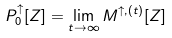Convert formula to latex. <formula><loc_0><loc_0><loc_500><loc_500>P ^ { \uparrow } _ { 0 } [ Z ] = \lim _ { t \to \infty } M ^ { \uparrow , ( t ) } [ Z ]</formula> 